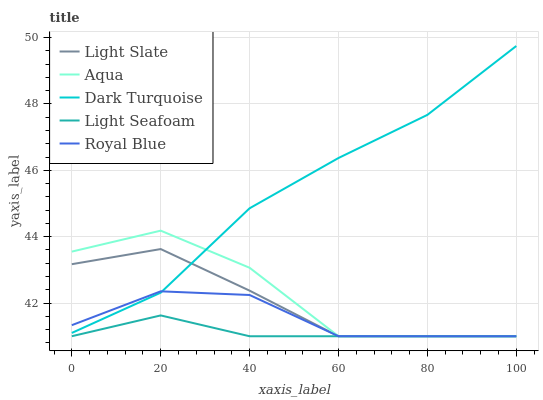Does Dark Turquoise have the minimum area under the curve?
Answer yes or no. No. Does Light Seafoam have the maximum area under the curve?
Answer yes or no. No. Is Dark Turquoise the smoothest?
Answer yes or no. No. Is Dark Turquoise the roughest?
Answer yes or no. No. Does Dark Turquoise have the lowest value?
Answer yes or no. No. Does Light Seafoam have the highest value?
Answer yes or no. No. Is Light Seafoam less than Dark Turquoise?
Answer yes or no. Yes. Is Dark Turquoise greater than Light Seafoam?
Answer yes or no. Yes. Does Light Seafoam intersect Dark Turquoise?
Answer yes or no. No. 